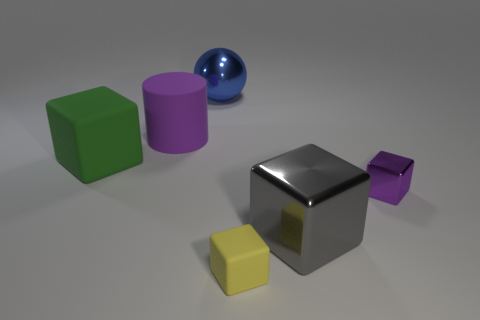Subtract all small purple metal cubes. How many cubes are left? 3 Add 3 purple cylinders. How many objects exist? 9 Subtract all purple blocks. How many blocks are left? 3 Subtract 2 cubes. How many cubes are left? 2 Subtract all cylinders. How many objects are left? 5 Subtract 1 blue balls. How many objects are left? 5 Subtract all gray spheres. Subtract all red cylinders. How many spheres are left? 1 Subtract all blue blocks. How many red spheres are left? 0 Subtract all tiny purple shiny things. Subtract all yellow metal balls. How many objects are left? 5 Add 2 tiny yellow rubber cubes. How many tiny yellow rubber cubes are left? 3 